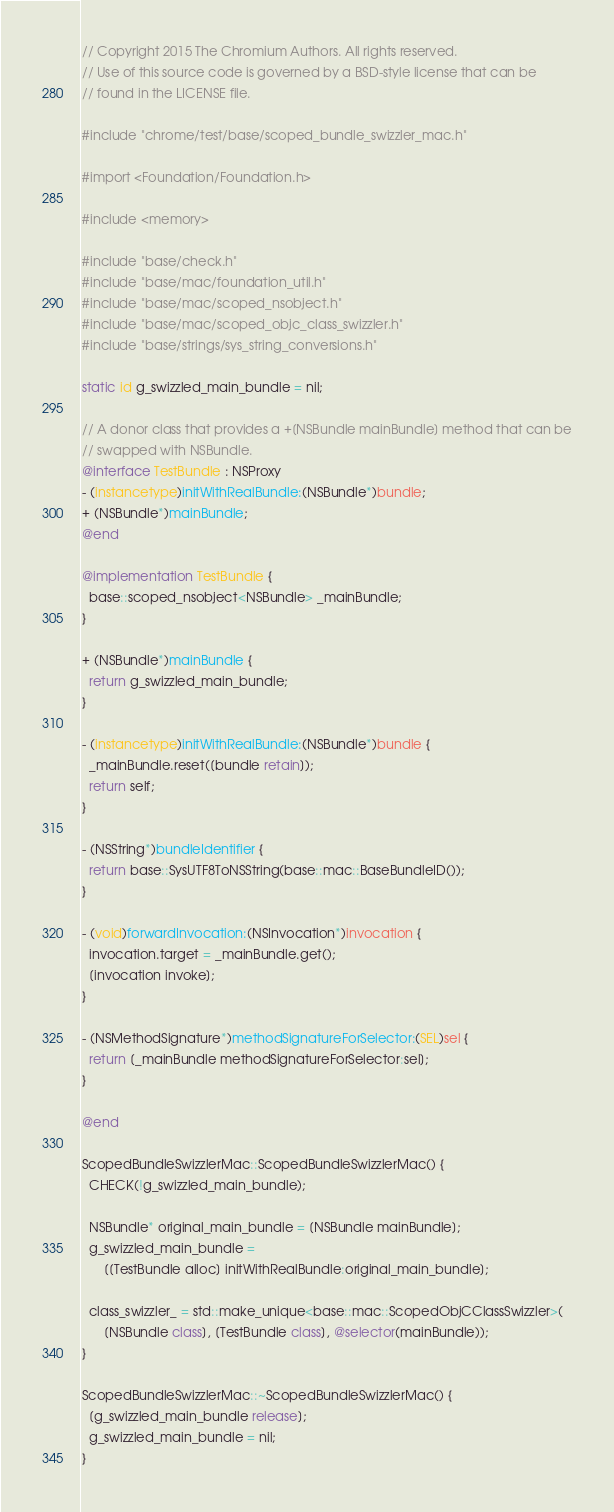Convert code to text. <code><loc_0><loc_0><loc_500><loc_500><_ObjectiveC_>// Copyright 2015 The Chromium Authors. All rights reserved.
// Use of this source code is governed by a BSD-style license that can be
// found in the LICENSE file.

#include "chrome/test/base/scoped_bundle_swizzler_mac.h"

#import <Foundation/Foundation.h>

#include <memory>

#include "base/check.h"
#include "base/mac/foundation_util.h"
#include "base/mac/scoped_nsobject.h"
#include "base/mac/scoped_objc_class_swizzler.h"
#include "base/strings/sys_string_conversions.h"

static id g_swizzled_main_bundle = nil;

// A donor class that provides a +[NSBundle mainBundle] method that can be
// swapped with NSBundle.
@interface TestBundle : NSProxy
- (instancetype)initWithRealBundle:(NSBundle*)bundle;
+ (NSBundle*)mainBundle;
@end

@implementation TestBundle {
  base::scoped_nsobject<NSBundle> _mainBundle;
}

+ (NSBundle*)mainBundle {
  return g_swizzled_main_bundle;
}

- (instancetype)initWithRealBundle:(NSBundle*)bundle {
  _mainBundle.reset([bundle retain]);
  return self;
}

- (NSString*)bundleIdentifier {
  return base::SysUTF8ToNSString(base::mac::BaseBundleID());
}

- (void)forwardInvocation:(NSInvocation*)invocation {
  invocation.target = _mainBundle.get();
  [invocation invoke];
}

- (NSMethodSignature*)methodSignatureForSelector:(SEL)sel {
  return [_mainBundle methodSignatureForSelector:sel];
}

@end

ScopedBundleSwizzlerMac::ScopedBundleSwizzlerMac() {
  CHECK(!g_swizzled_main_bundle);

  NSBundle* original_main_bundle = [NSBundle mainBundle];
  g_swizzled_main_bundle =
      [[TestBundle alloc] initWithRealBundle:original_main_bundle];

  class_swizzler_ = std::make_unique<base::mac::ScopedObjCClassSwizzler>(
      [NSBundle class], [TestBundle class], @selector(mainBundle));
}

ScopedBundleSwizzlerMac::~ScopedBundleSwizzlerMac() {
  [g_swizzled_main_bundle release];
  g_swizzled_main_bundle = nil;
}
</code> 